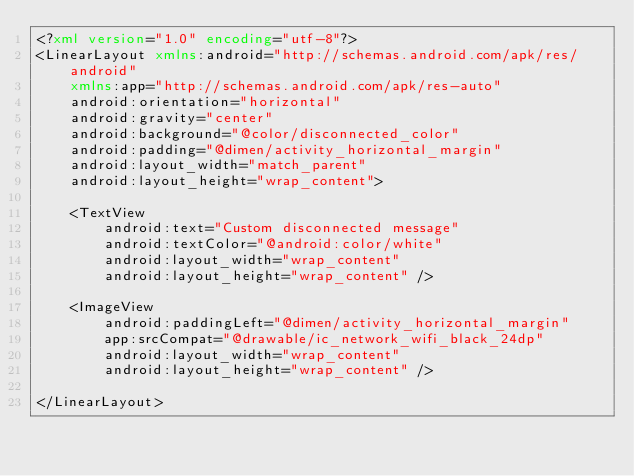Convert code to text. <code><loc_0><loc_0><loc_500><loc_500><_XML_><?xml version="1.0" encoding="utf-8"?>
<LinearLayout xmlns:android="http://schemas.android.com/apk/res/android"
    xmlns:app="http://schemas.android.com/apk/res-auto"
    android:orientation="horizontal"
    android:gravity="center"
    android:background="@color/disconnected_color"
    android:padding="@dimen/activity_horizontal_margin"
    android:layout_width="match_parent"
    android:layout_height="wrap_content">

    <TextView
        android:text="Custom disconnected message"
        android:textColor="@android:color/white"
        android:layout_width="wrap_content"
        android:layout_height="wrap_content" />

    <ImageView
        android:paddingLeft="@dimen/activity_horizontal_margin"
        app:srcCompat="@drawable/ic_network_wifi_black_24dp"
        android:layout_width="wrap_content"
        android:layout_height="wrap_content" />

</LinearLayout></code> 